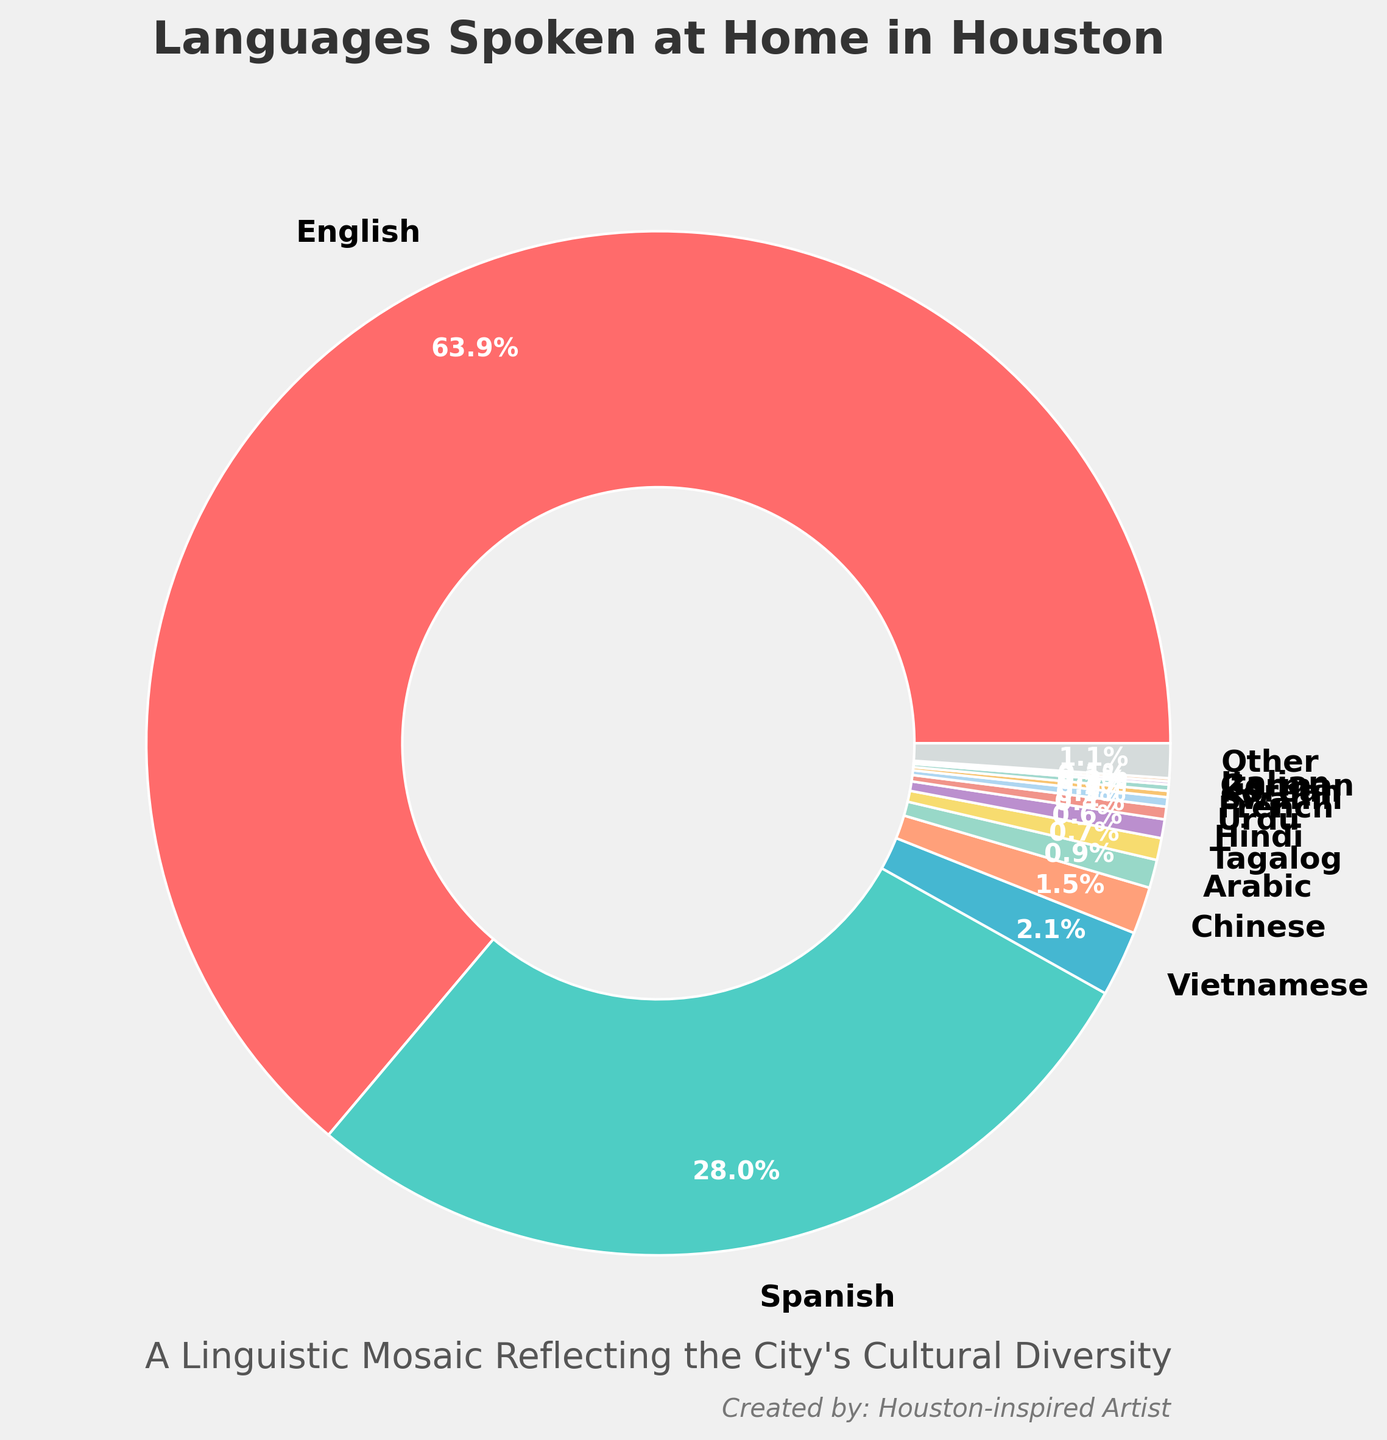Which language is spoken at home by the majority of Houston residents? By looking at the largest section in the pie chart, which is visually the simplest operation, it is clear that English has the largest proportion.
Answer: English What is the combined percentage of residents speaking Spanish and Vietnamese at home? To find the combined percentage, locate the Spanish and Vietnamese segments on the pie chart and add their percentages: Spanish (28.3%) + Vietnamese (2.1%).
Answer: 30.4% How do the percentages of Chinese and Arabic speakers compare? Find the segments for Chinese and Arabic in the pie chart, then compare their values: Chinese (1.5%) and Arabic (0.9%).
Answer: Chinese has a higher percentage than Arabic Which non-English language is most commonly spoken at home in Houston? Identify the largest segment among the non-English languages. Spanish has the largest proportion after English in the pie chart.
Answer: Spanish What is the total percentage of languages spoken at home that have a smaller proportion than Tagalog? Identify all languages with percentages smaller than Tagalog (0.7%) and sum them: Hindi (0.6%) + Urdu (0.4%) + French (0.3%) + Swahili (0.2%) + Korean (0.2%) + German (0.1%) + Italian (0.1%).
Answer: 1.9% What is the difference between the proportions of English and all other languages combined? First, find the percentage of all other languages by summing the non-English percentages (100% - 64.5% = 35.5%), then subtract this from the English percentage: 64.5% - 35.5%.
Answer: 29% How do the percentages of Vietnamese and Tagalog speakers compare? Locate the segments in the pie chart and note their percentages: Vietnamese (2.1%) and Tagalog (0.7%).
Answer: Vietnamese has a larger percentage What percentage of languages other than English and Spanish are spoken at home? Sum the percentages of all languages except for English and Spanish: Vietnamese (2.1%) + Chinese (1.5%) + Arabic (0.9%) + Tagalog (0.7%) + Hindi (0.6%) + Urdu (0.4%) + French (0.3%) + Swahili (0.2%) + Korean (0.2%) + German (0.1%) + Italian (0.1%) + Other (1.1%).
Answer: 8.1% What is the visual significance of the subtitle in the chart? The subtitle, "A Linguistic Mosaic Reflecting the City's Cultural Diversity," visually emphasizes the diverse languages spoken in Houston by explaining the significance of the data presented in the pie chart.
Answer: It highlights Houston's cultural diversity 